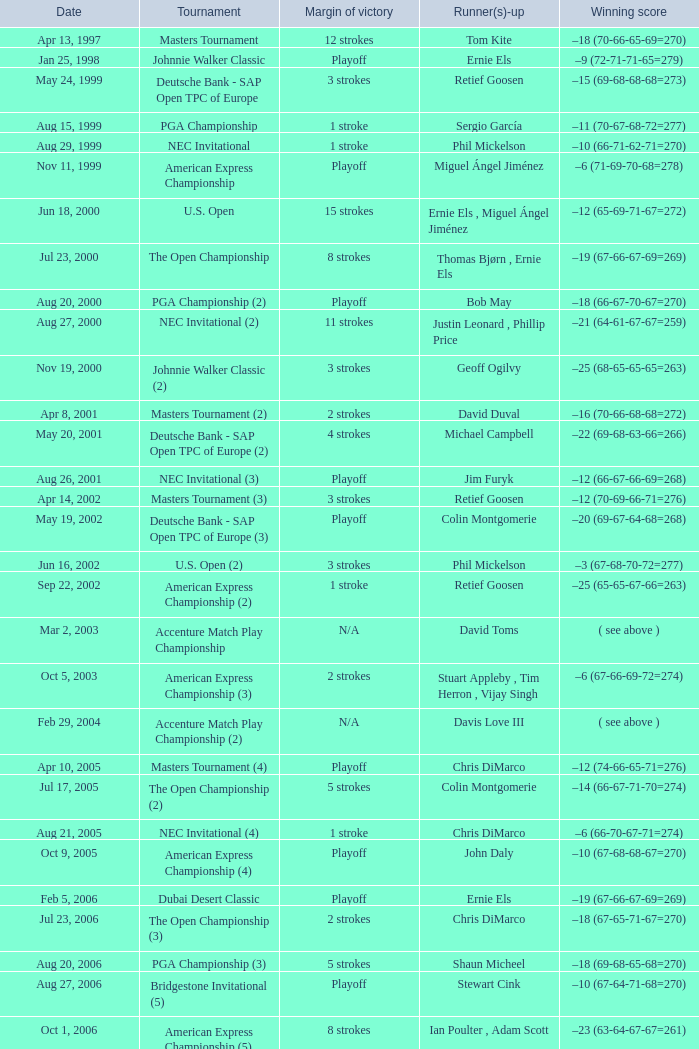Who is Runner(s)-up that has a Date of may 24, 1999? Retief Goosen. 